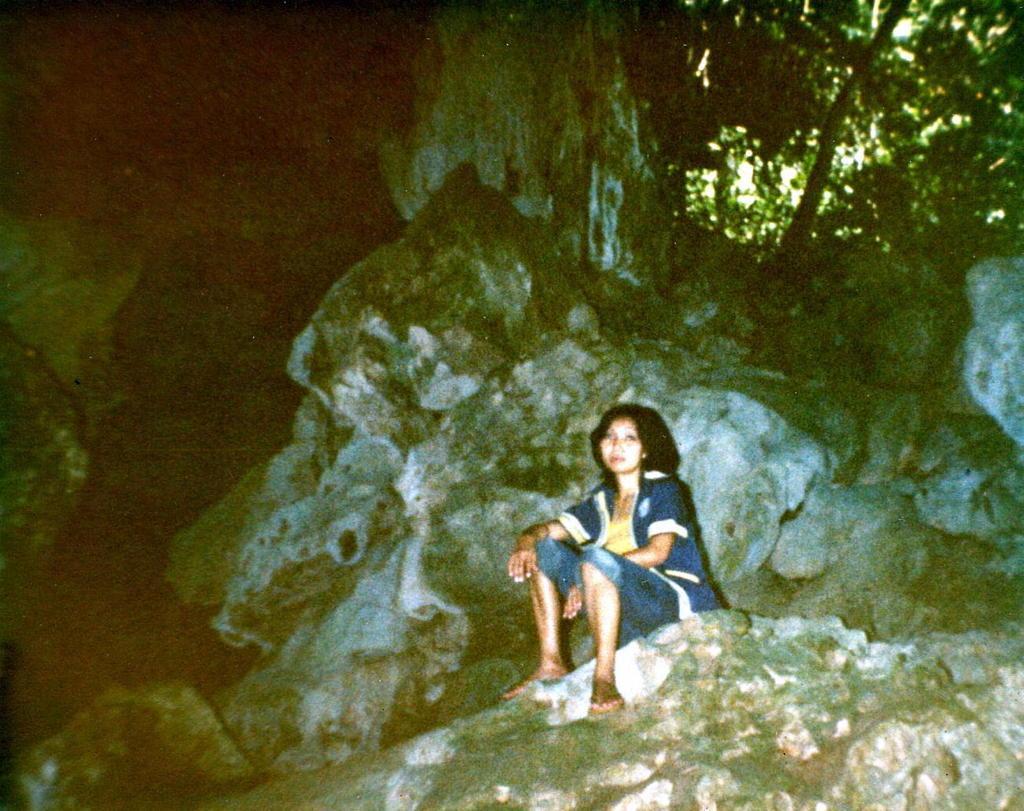Could you give a brief overview of what you see in this image? In this image I can see a woman wearing yellow dress, blue jacket, blue jeans is sitting on the rock. In the background I can see a tree and few rocks. 